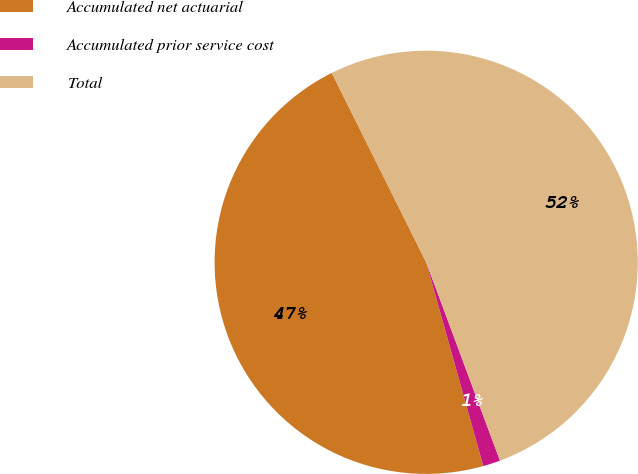Convert chart to OTSL. <chart><loc_0><loc_0><loc_500><loc_500><pie_chart><fcel>Accumulated net actuarial<fcel>Accumulated prior service cost<fcel>Total<nl><fcel>46.99%<fcel>1.32%<fcel>51.69%<nl></chart> 